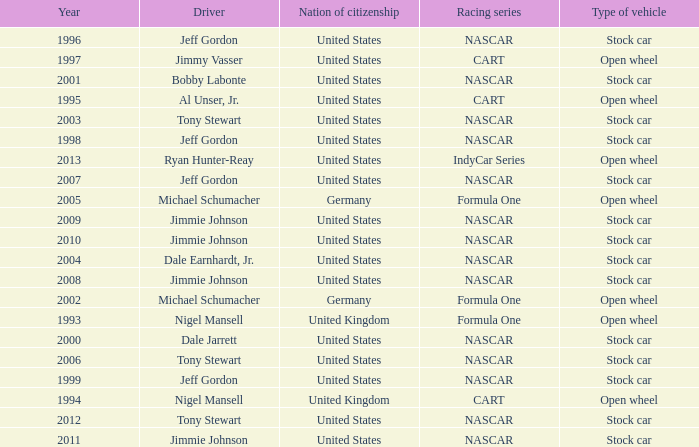What driver has a stock car vehicle with a year of 1999? Jeff Gordon. 